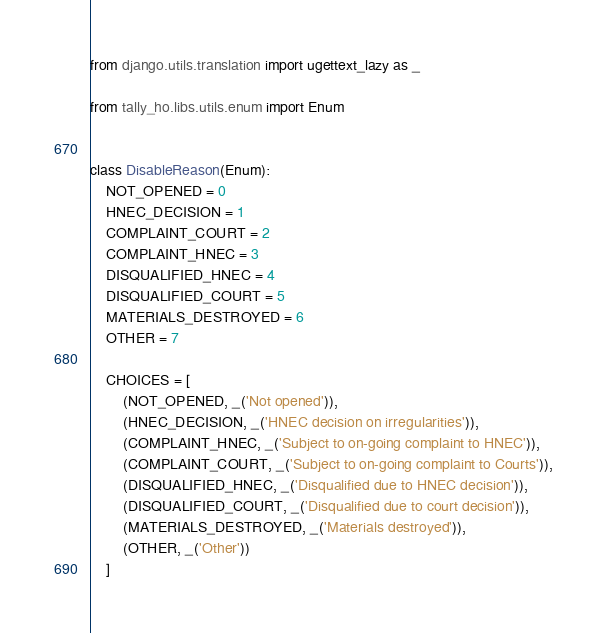<code> <loc_0><loc_0><loc_500><loc_500><_Python_>from django.utils.translation import ugettext_lazy as _

from tally_ho.libs.utils.enum import Enum


class DisableReason(Enum):
    NOT_OPENED = 0
    HNEC_DECISION = 1
    COMPLAINT_COURT = 2
    COMPLAINT_HNEC = 3
    DISQUALIFIED_HNEC = 4
    DISQUALIFIED_COURT = 5
    MATERIALS_DESTROYED = 6
    OTHER = 7

    CHOICES = [
        (NOT_OPENED, _('Not opened')),
        (HNEC_DECISION, _('HNEC decision on irregularities')),
        (COMPLAINT_HNEC, _('Subject to on-going complaint to HNEC')),
        (COMPLAINT_COURT, _('Subject to on-going complaint to Courts')),
        (DISQUALIFIED_HNEC, _('Disqualified due to HNEC decision')),
        (DISQUALIFIED_COURT, _('Disqualified due to court decision')),
        (MATERIALS_DESTROYED, _('Materials destroyed')),
        (OTHER, _('Other'))
    ]
</code> 